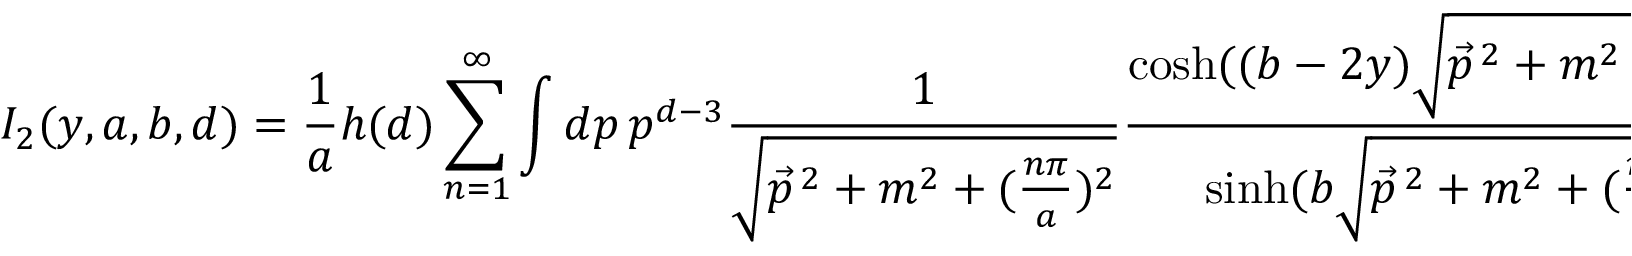<formula> <loc_0><loc_0><loc_500><loc_500>I _ { 2 } ( y , a , b , d ) = \frac { 1 } { a } h ( d ) \sum _ { n = 1 } ^ { \infty } \int d p \, p ^ { d - 3 } \frac { 1 } { \sqrt { \vec { p } ^ { \, 2 } + m ^ { 2 } + ( \frac { n \pi } { a } ) ^ { 2 } } } \frac { \cosh ( ( b - 2 y ) \sqrt { \vec { p } ^ { \, 2 } + m ^ { 2 } + ( \frac { n \pi } { a } ) ^ { 2 } } ) } { \sinh ( b \sqrt { \vec { p } ^ { \, 2 } + m ^ { 2 } + ( \frac { n \pi } { a } ) ^ { 2 } } ) }</formula> 